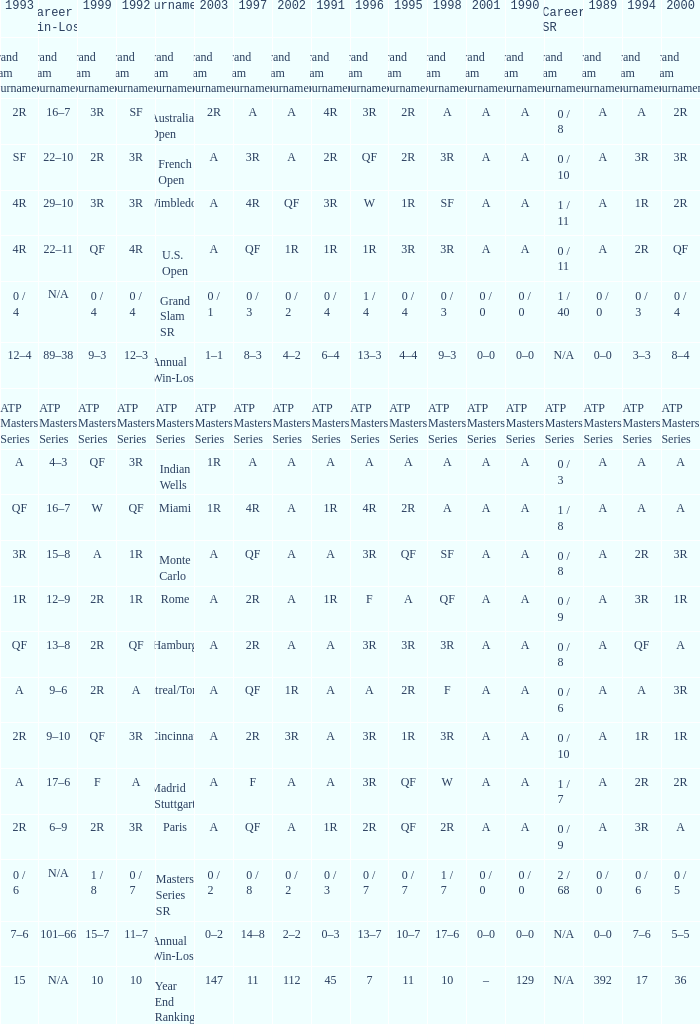What is the value in 1997 when the value in 1989 is A, 1995 is QF, 1996 is 3R and the career SR is 0 / 8? QF. 